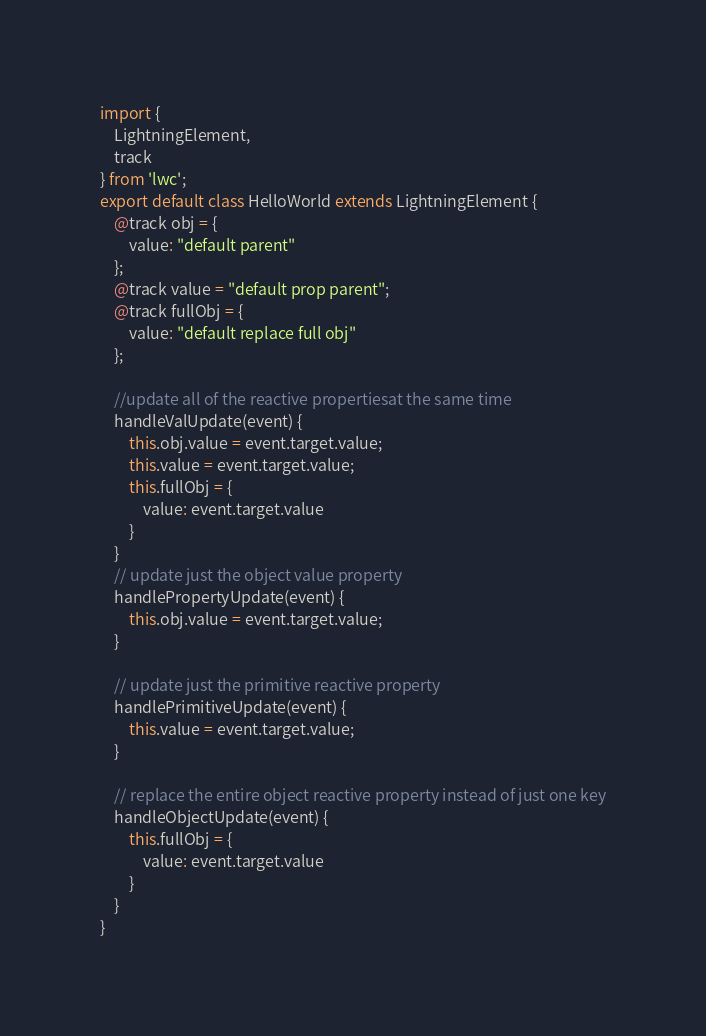Convert code to text. <code><loc_0><loc_0><loc_500><loc_500><_JavaScript_>import {
    LightningElement,
    track
} from 'lwc';
export default class HelloWorld extends LightningElement {
    @track obj = {
        value: "default parent"
    };
    @track value = "default prop parent";
    @track fullObj = {
        value: "default replace full obj"
    };

    //update all of the reactive propertiesat the same time
    handleValUpdate(event) {
        this.obj.value = event.target.value;
        this.value = event.target.value;
        this.fullObj = {
            value: event.target.value
        }
    }
    // update just the object value property
    handlePropertyUpdate(event) {
        this.obj.value = event.target.value;
    }

    // update just the primitive reactive property
    handlePrimitiveUpdate(event) {
        this.value = event.target.value;
    }

    // replace the entire object reactive property instead of just one key
    handleObjectUpdate(event) {
        this.fullObj = {
            value: event.target.value
        }
    }
}</code> 